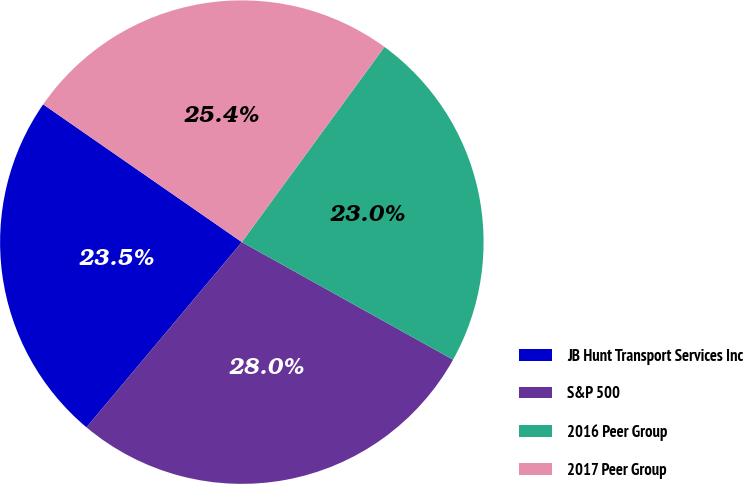Convert chart to OTSL. <chart><loc_0><loc_0><loc_500><loc_500><pie_chart><fcel>JB Hunt Transport Services Inc<fcel>S&P 500<fcel>2016 Peer Group<fcel>2017 Peer Group<nl><fcel>23.54%<fcel>28.02%<fcel>23.04%<fcel>25.39%<nl></chart> 